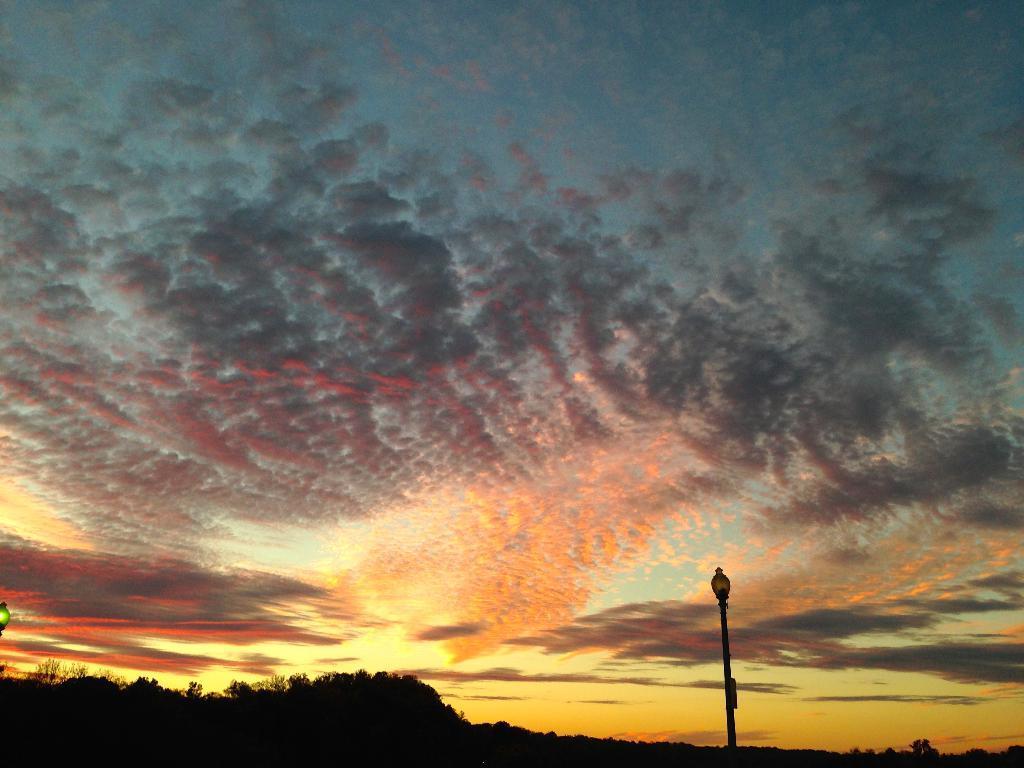How would you summarize this image in a sentence or two? This image is taken during the sunset, where we can see there is a pole on the right side. On the left side bottom there are trees. At the top there is the sky. 